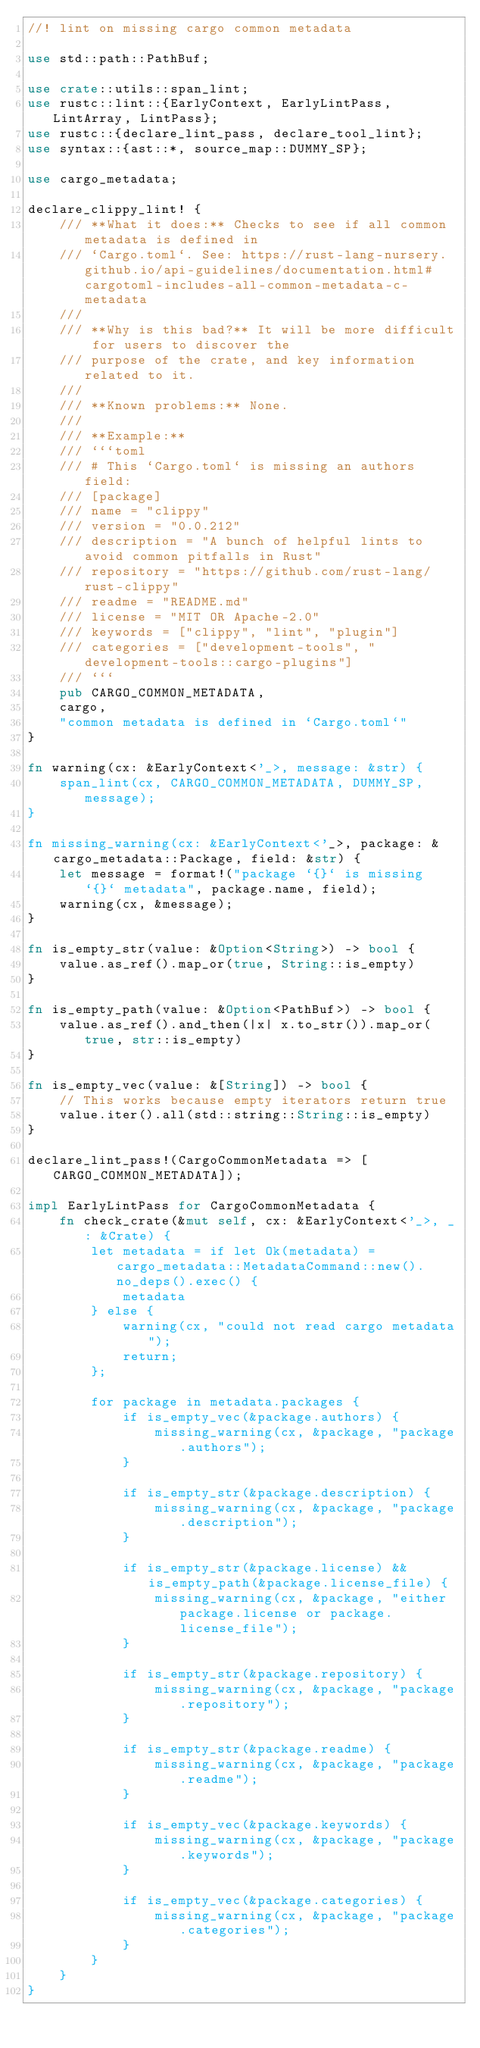Convert code to text. <code><loc_0><loc_0><loc_500><loc_500><_Rust_>//! lint on missing cargo common metadata

use std::path::PathBuf;

use crate::utils::span_lint;
use rustc::lint::{EarlyContext, EarlyLintPass, LintArray, LintPass};
use rustc::{declare_lint_pass, declare_tool_lint};
use syntax::{ast::*, source_map::DUMMY_SP};

use cargo_metadata;

declare_clippy_lint! {
    /// **What it does:** Checks to see if all common metadata is defined in
    /// `Cargo.toml`. See: https://rust-lang-nursery.github.io/api-guidelines/documentation.html#cargotoml-includes-all-common-metadata-c-metadata
    ///
    /// **Why is this bad?** It will be more difficult for users to discover the
    /// purpose of the crate, and key information related to it.
    ///
    /// **Known problems:** None.
    ///
    /// **Example:**
    /// ```toml
    /// # This `Cargo.toml` is missing an authors field:
    /// [package]
    /// name = "clippy"
    /// version = "0.0.212"
    /// description = "A bunch of helpful lints to avoid common pitfalls in Rust"
    /// repository = "https://github.com/rust-lang/rust-clippy"
    /// readme = "README.md"
    /// license = "MIT OR Apache-2.0"
    /// keywords = ["clippy", "lint", "plugin"]
    /// categories = ["development-tools", "development-tools::cargo-plugins"]
    /// ```
    pub CARGO_COMMON_METADATA,
    cargo,
    "common metadata is defined in `Cargo.toml`"
}

fn warning(cx: &EarlyContext<'_>, message: &str) {
    span_lint(cx, CARGO_COMMON_METADATA, DUMMY_SP, message);
}

fn missing_warning(cx: &EarlyContext<'_>, package: &cargo_metadata::Package, field: &str) {
    let message = format!("package `{}` is missing `{}` metadata", package.name, field);
    warning(cx, &message);
}

fn is_empty_str(value: &Option<String>) -> bool {
    value.as_ref().map_or(true, String::is_empty)
}

fn is_empty_path(value: &Option<PathBuf>) -> bool {
    value.as_ref().and_then(|x| x.to_str()).map_or(true, str::is_empty)
}

fn is_empty_vec(value: &[String]) -> bool {
    // This works because empty iterators return true
    value.iter().all(std::string::String::is_empty)
}

declare_lint_pass!(CargoCommonMetadata => [CARGO_COMMON_METADATA]);

impl EarlyLintPass for CargoCommonMetadata {
    fn check_crate(&mut self, cx: &EarlyContext<'_>, _: &Crate) {
        let metadata = if let Ok(metadata) = cargo_metadata::MetadataCommand::new().no_deps().exec() {
            metadata
        } else {
            warning(cx, "could not read cargo metadata");
            return;
        };

        for package in metadata.packages {
            if is_empty_vec(&package.authors) {
                missing_warning(cx, &package, "package.authors");
            }

            if is_empty_str(&package.description) {
                missing_warning(cx, &package, "package.description");
            }

            if is_empty_str(&package.license) && is_empty_path(&package.license_file) {
                missing_warning(cx, &package, "either package.license or package.license_file");
            }

            if is_empty_str(&package.repository) {
                missing_warning(cx, &package, "package.repository");
            }

            if is_empty_str(&package.readme) {
                missing_warning(cx, &package, "package.readme");
            }

            if is_empty_vec(&package.keywords) {
                missing_warning(cx, &package, "package.keywords");
            }

            if is_empty_vec(&package.categories) {
                missing_warning(cx, &package, "package.categories");
            }
        }
    }
}
</code> 